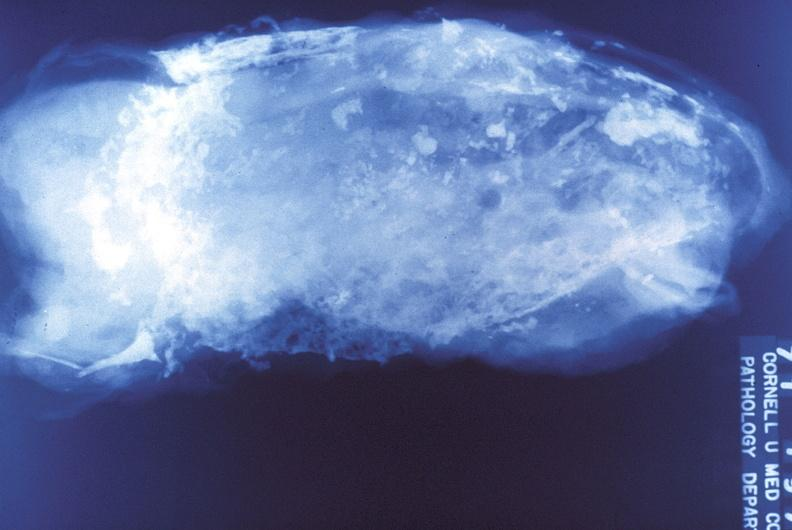s traumatic rupture present?
Answer the question using a single word or phrase. No 